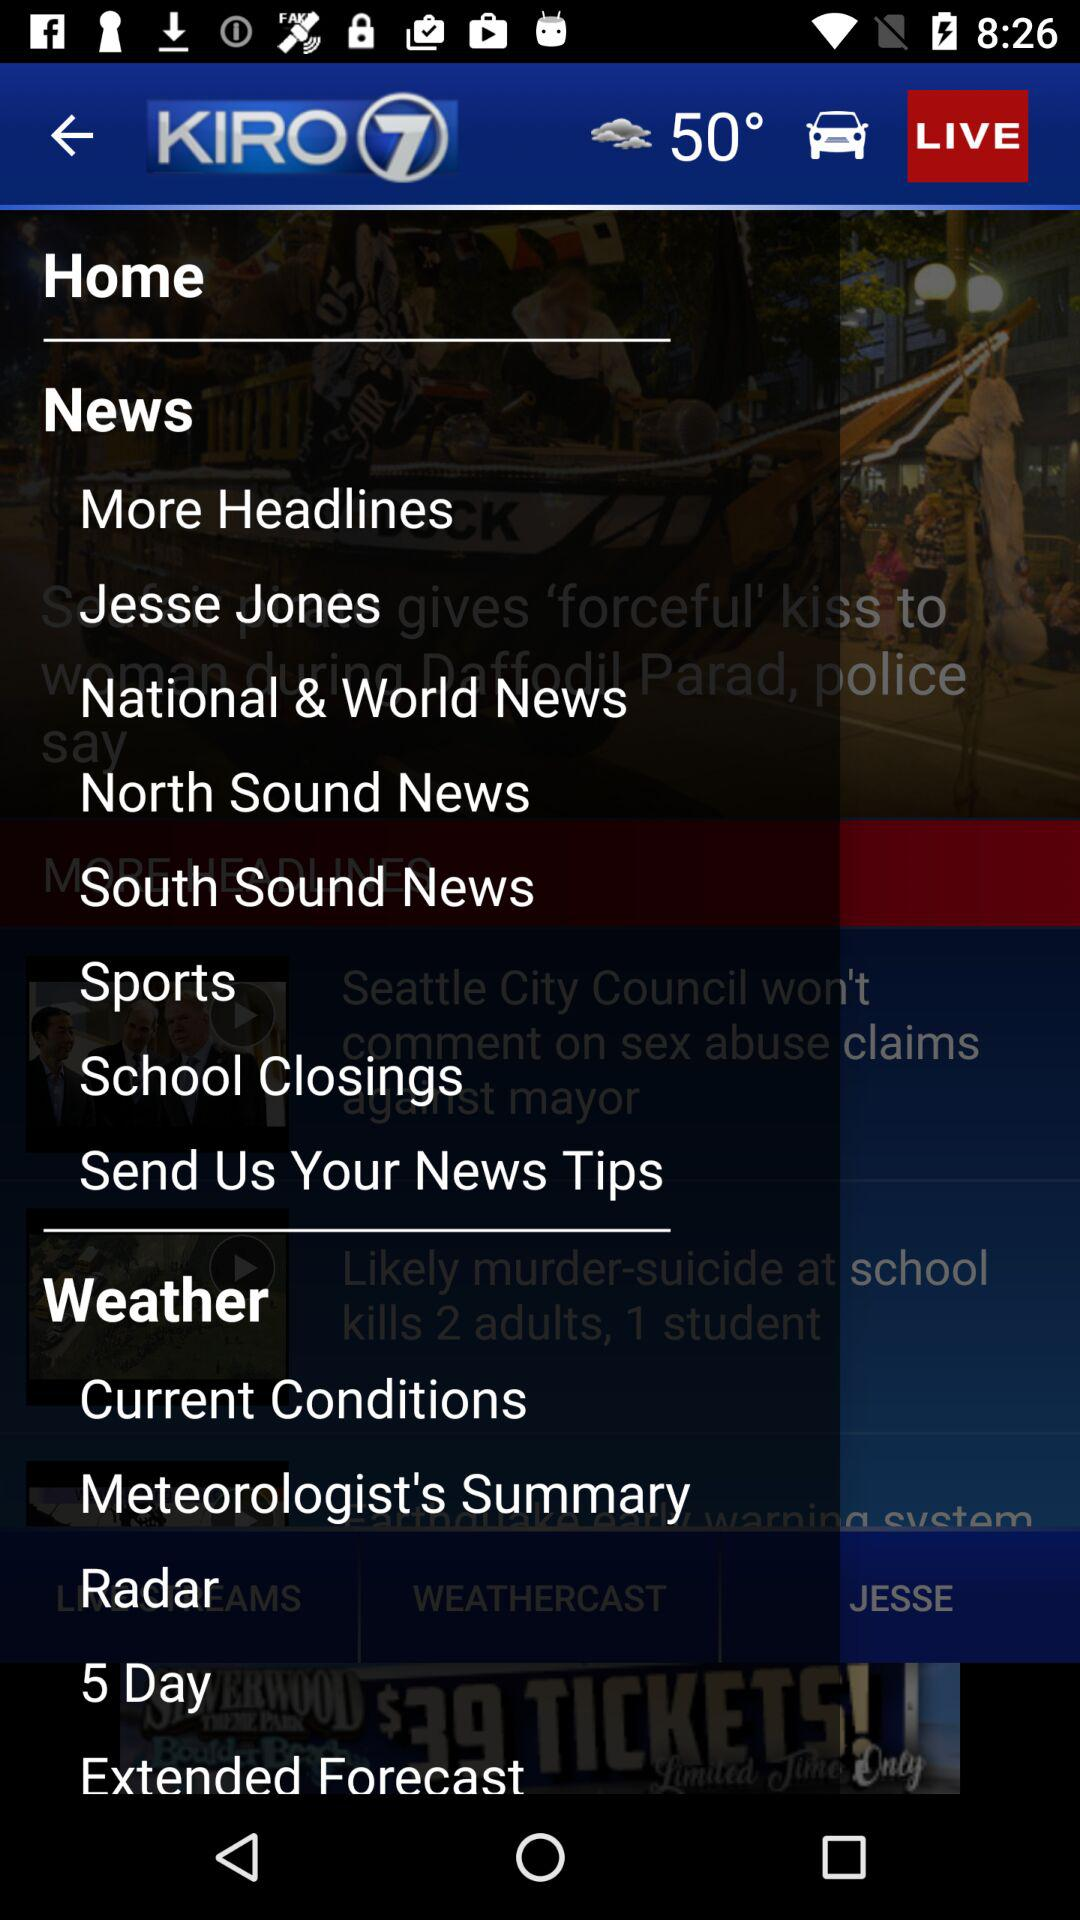What is the application name? The application name is "KIRO 7". 